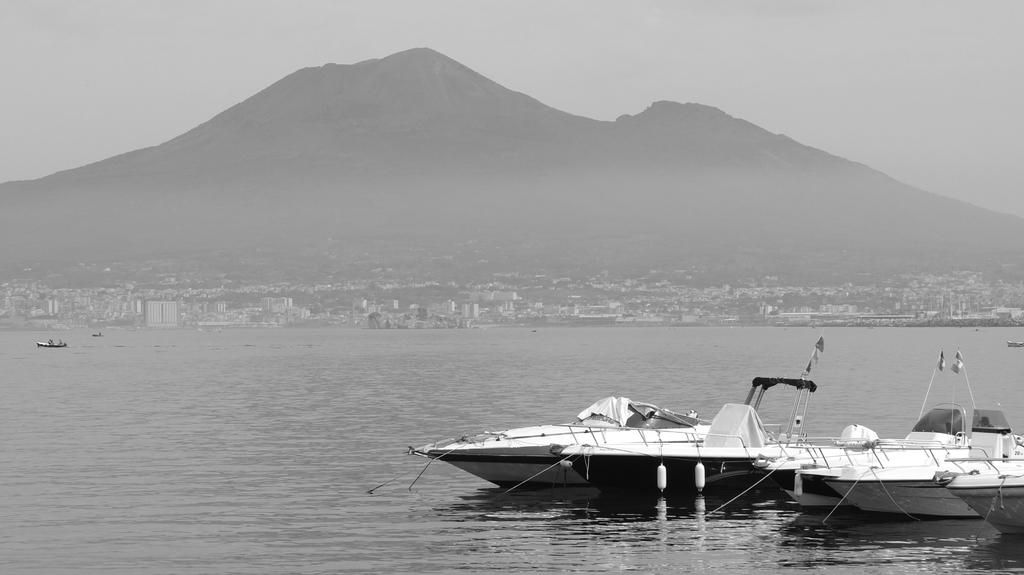What is the color scheme of the image? The image is black and white. What can be seen on the water in the image? There are boats on the water in the image. What type of urban landscape is visible in the image? The image shows a view of the city, with buildings and skyscrapers visible. What natural feature can be seen in the image? There appears to be a mountain in the image. What type of brake system is installed on the boats in the image? There is no information about the boats' brake systems in the image, as it is a black and white image focused on the city view and the mountain. 